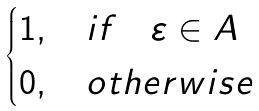Convert formula to latex. <formula><loc_0><loc_0><loc_500><loc_500>\begin{cases} 1 , \quad i f \quad \varepsilon \in A \\ 0 , \quad o t h e r w i s e \end{cases}</formula> 